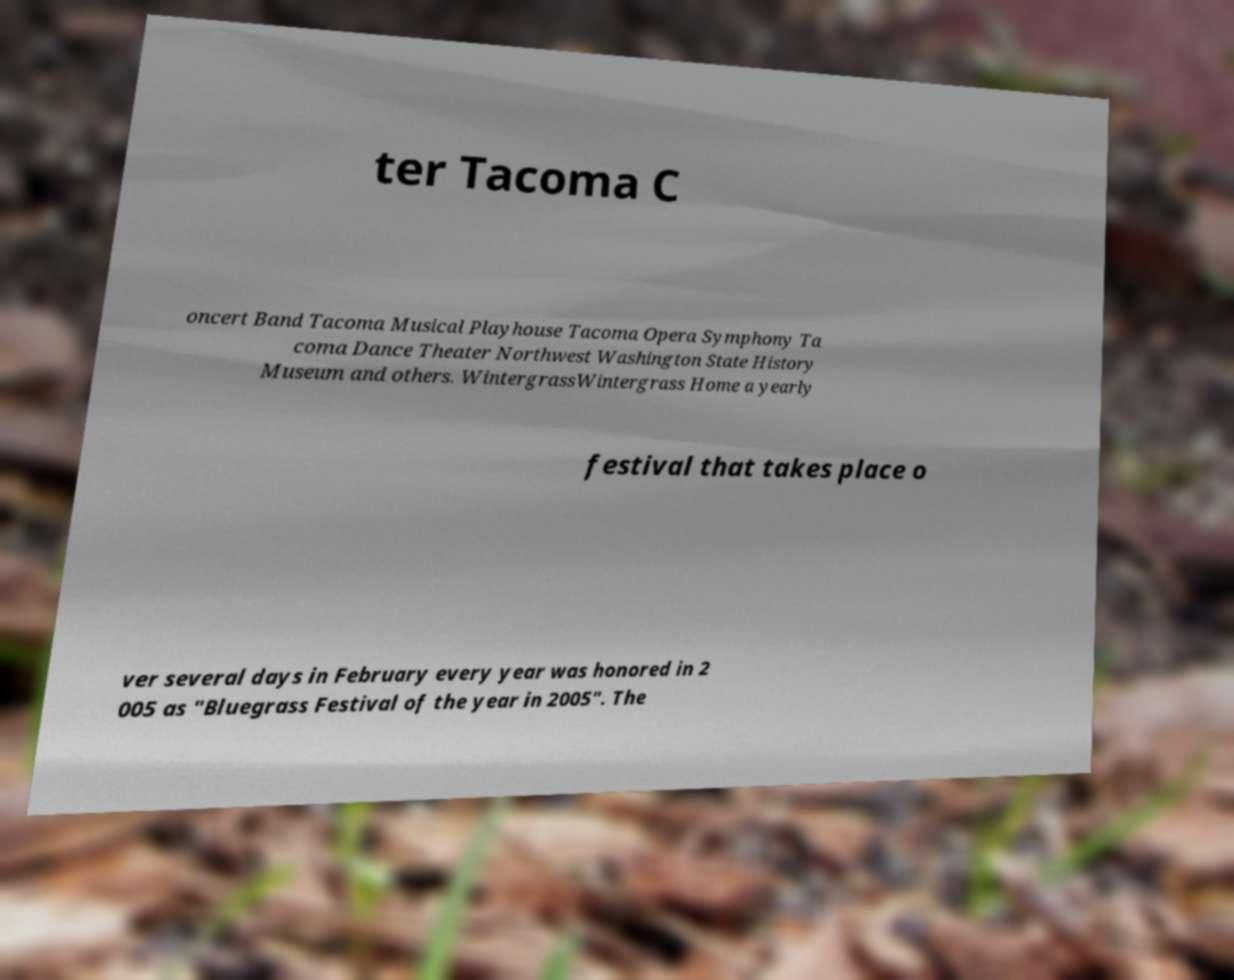Please identify and transcribe the text found in this image. ter Tacoma C oncert Band Tacoma Musical Playhouse Tacoma Opera Symphony Ta coma Dance Theater Northwest Washington State History Museum and others. WintergrassWintergrass Home a yearly festival that takes place o ver several days in February every year was honored in 2 005 as "Bluegrass Festival of the year in 2005". The 